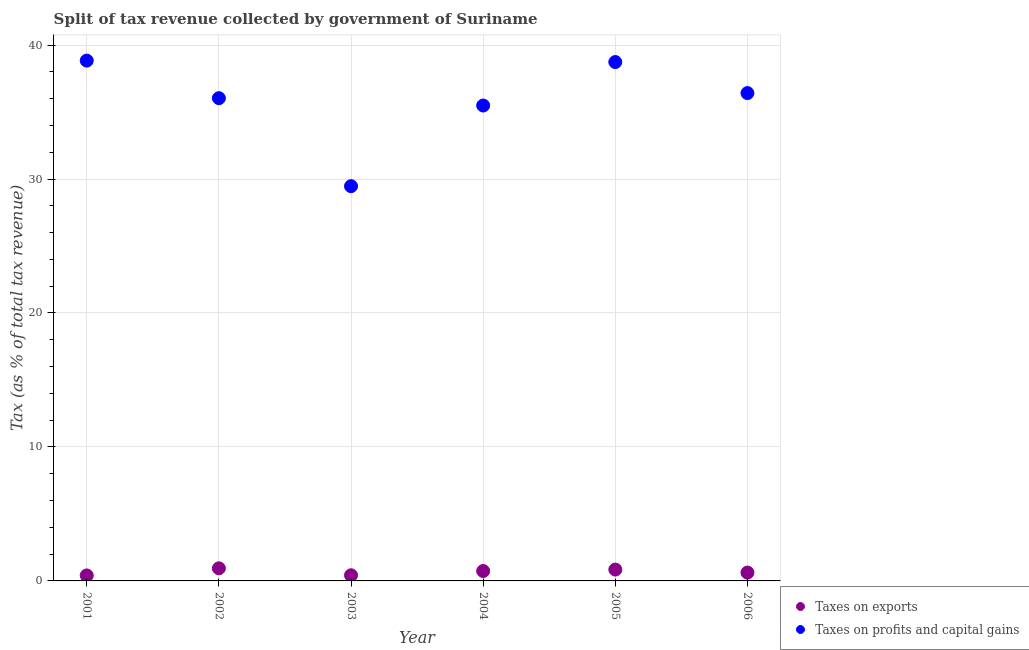What is the percentage of revenue obtained from taxes on profits and capital gains in 2004?
Ensure brevity in your answer.  35.49. Across all years, what is the maximum percentage of revenue obtained from taxes on exports?
Ensure brevity in your answer.  0.94. Across all years, what is the minimum percentage of revenue obtained from taxes on profits and capital gains?
Make the answer very short. 29.47. In which year was the percentage of revenue obtained from taxes on profits and capital gains maximum?
Offer a terse response. 2001. In which year was the percentage of revenue obtained from taxes on profits and capital gains minimum?
Make the answer very short. 2003. What is the total percentage of revenue obtained from taxes on profits and capital gains in the graph?
Give a very brief answer. 214.98. What is the difference between the percentage of revenue obtained from taxes on profits and capital gains in 2005 and that in 2006?
Your response must be concise. 2.32. What is the difference between the percentage of revenue obtained from taxes on profits and capital gains in 2003 and the percentage of revenue obtained from taxes on exports in 2002?
Provide a short and direct response. 28.53. What is the average percentage of revenue obtained from taxes on exports per year?
Provide a succinct answer. 0.66. In the year 2001, what is the difference between the percentage of revenue obtained from taxes on exports and percentage of revenue obtained from taxes on profits and capital gains?
Your answer should be compact. -38.43. What is the ratio of the percentage of revenue obtained from taxes on profits and capital gains in 2002 to that in 2006?
Ensure brevity in your answer.  0.99. Is the percentage of revenue obtained from taxes on exports in 2002 less than that in 2006?
Offer a very short reply. No. What is the difference between the highest and the second highest percentage of revenue obtained from taxes on profits and capital gains?
Offer a very short reply. 0.11. What is the difference between the highest and the lowest percentage of revenue obtained from taxes on profits and capital gains?
Offer a terse response. 9.37. In how many years, is the percentage of revenue obtained from taxes on exports greater than the average percentage of revenue obtained from taxes on exports taken over all years?
Offer a terse response. 3. Is the sum of the percentage of revenue obtained from taxes on exports in 2001 and 2004 greater than the maximum percentage of revenue obtained from taxes on profits and capital gains across all years?
Offer a terse response. No. How many dotlines are there?
Your response must be concise. 2. How many legend labels are there?
Your response must be concise. 2. How are the legend labels stacked?
Provide a succinct answer. Vertical. What is the title of the graph?
Offer a very short reply. Split of tax revenue collected by government of Suriname. What is the label or title of the Y-axis?
Ensure brevity in your answer.  Tax (as % of total tax revenue). What is the Tax (as % of total tax revenue) of Taxes on exports in 2001?
Provide a short and direct response. 0.41. What is the Tax (as % of total tax revenue) of Taxes on profits and capital gains in 2001?
Offer a very short reply. 38.84. What is the Tax (as % of total tax revenue) of Taxes on exports in 2002?
Your response must be concise. 0.94. What is the Tax (as % of total tax revenue) of Taxes on profits and capital gains in 2002?
Offer a very short reply. 36.04. What is the Tax (as % of total tax revenue) of Taxes on exports in 2003?
Give a very brief answer. 0.42. What is the Tax (as % of total tax revenue) in Taxes on profits and capital gains in 2003?
Provide a short and direct response. 29.47. What is the Tax (as % of total tax revenue) in Taxes on exports in 2004?
Give a very brief answer. 0.74. What is the Tax (as % of total tax revenue) in Taxes on profits and capital gains in 2004?
Your answer should be compact. 35.49. What is the Tax (as % of total tax revenue) in Taxes on exports in 2005?
Offer a terse response. 0.85. What is the Tax (as % of total tax revenue) of Taxes on profits and capital gains in 2005?
Offer a very short reply. 38.73. What is the Tax (as % of total tax revenue) in Taxes on exports in 2006?
Your response must be concise. 0.62. What is the Tax (as % of total tax revenue) of Taxes on profits and capital gains in 2006?
Your answer should be very brief. 36.42. Across all years, what is the maximum Tax (as % of total tax revenue) in Taxes on exports?
Give a very brief answer. 0.94. Across all years, what is the maximum Tax (as % of total tax revenue) in Taxes on profits and capital gains?
Your answer should be compact. 38.84. Across all years, what is the minimum Tax (as % of total tax revenue) in Taxes on exports?
Give a very brief answer. 0.41. Across all years, what is the minimum Tax (as % of total tax revenue) of Taxes on profits and capital gains?
Provide a succinct answer. 29.47. What is the total Tax (as % of total tax revenue) of Taxes on exports in the graph?
Ensure brevity in your answer.  3.98. What is the total Tax (as % of total tax revenue) of Taxes on profits and capital gains in the graph?
Provide a succinct answer. 214.98. What is the difference between the Tax (as % of total tax revenue) of Taxes on exports in 2001 and that in 2002?
Make the answer very short. -0.53. What is the difference between the Tax (as % of total tax revenue) in Taxes on profits and capital gains in 2001 and that in 2002?
Your answer should be very brief. 2.8. What is the difference between the Tax (as % of total tax revenue) in Taxes on exports in 2001 and that in 2003?
Provide a short and direct response. -0.01. What is the difference between the Tax (as % of total tax revenue) in Taxes on profits and capital gains in 2001 and that in 2003?
Provide a short and direct response. 9.37. What is the difference between the Tax (as % of total tax revenue) in Taxes on exports in 2001 and that in 2004?
Offer a very short reply. -0.33. What is the difference between the Tax (as % of total tax revenue) of Taxes on profits and capital gains in 2001 and that in 2004?
Provide a succinct answer. 3.35. What is the difference between the Tax (as % of total tax revenue) of Taxes on exports in 2001 and that in 2005?
Your answer should be very brief. -0.44. What is the difference between the Tax (as % of total tax revenue) in Taxes on profits and capital gains in 2001 and that in 2005?
Keep it short and to the point. 0.11. What is the difference between the Tax (as % of total tax revenue) in Taxes on exports in 2001 and that in 2006?
Your response must be concise. -0.21. What is the difference between the Tax (as % of total tax revenue) in Taxes on profits and capital gains in 2001 and that in 2006?
Offer a terse response. 2.42. What is the difference between the Tax (as % of total tax revenue) in Taxes on exports in 2002 and that in 2003?
Provide a succinct answer. 0.52. What is the difference between the Tax (as % of total tax revenue) of Taxes on profits and capital gains in 2002 and that in 2003?
Offer a very short reply. 6.57. What is the difference between the Tax (as % of total tax revenue) of Taxes on exports in 2002 and that in 2004?
Give a very brief answer. 0.2. What is the difference between the Tax (as % of total tax revenue) in Taxes on profits and capital gains in 2002 and that in 2004?
Your response must be concise. 0.55. What is the difference between the Tax (as % of total tax revenue) in Taxes on exports in 2002 and that in 2005?
Make the answer very short. 0.09. What is the difference between the Tax (as % of total tax revenue) in Taxes on profits and capital gains in 2002 and that in 2005?
Your answer should be very brief. -2.7. What is the difference between the Tax (as % of total tax revenue) in Taxes on exports in 2002 and that in 2006?
Provide a short and direct response. 0.32. What is the difference between the Tax (as % of total tax revenue) of Taxes on profits and capital gains in 2002 and that in 2006?
Give a very brief answer. -0.38. What is the difference between the Tax (as % of total tax revenue) of Taxes on exports in 2003 and that in 2004?
Give a very brief answer. -0.32. What is the difference between the Tax (as % of total tax revenue) of Taxes on profits and capital gains in 2003 and that in 2004?
Provide a short and direct response. -6.02. What is the difference between the Tax (as % of total tax revenue) of Taxes on exports in 2003 and that in 2005?
Offer a very short reply. -0.42. What is the difference between the Tax (as % of total tax revenue) in Taxes on profits and capital gains in 2003 and that in 2005?
Ensure brevity in your answer.  -9.27. What is the difference between the Tax (as % of total tax revenue) of Taxes on exports in 2003 and that in 2006?
Offer a very short reply. -0.2. What is the difference between the Tax (as % of total tax revenue) in Taxes on profits and capital gains in 2003 and that in 2006?
Offer a very short reply. -6.95. What is the difference between the Tax (as % of total tax revenue) in Taxes on exports in 2004 and that in 2005?
Provide a short and direct response. -0.11. What is the difference between the Tax (as % of total tax revenue) in Taxes on profits and capital gains in 2004 and that in 2005?
Provide a succinct answer. -3.25. What is the difference between the Tax (as % of total tax revenue) of Taxes on exports in 2004 and that in 2006?
Keep it short and to the point. 0.12. What is the difference between the Tax (as % of total tax revenue) in Taxes on profits and capital gains in 2004 and that in 2006?
Ensure brevity in your answer.  -0.93. What is the difference between the Tax (as % of total tax revenue) of Taxes on exports in 2005 and that in 2006?
Your answer should be very brief. 0.23. What is the difference between the Tax (as % of total tax revenue) of Taxes on profits and capital gains in 2005 and that in 2006?
Your answer should be compact. 2.32. What is the difference between the Tax (as % of total tax revenue) of Taxes on exports in 2001 and the Tax (as % of total tax revenue) of Taxes on profits and capital gains in 2002?
Your answer should be compact. -35.63. What is the difference between the Tax (as % of total tax revenue) of Taxes on exports in 2001 and the Tax (as % of total tax revenue) of Taxes on profits and capital gains in 2003?
Provide a short and direct response. -29.06. What is the difference between the Tax (as % of total tax revenue) in Taxes on exports in 2001 and the Tax (as % of total tax revenue) in Taxes on profits and capital gains in 2004?
Make the answer very short. -35.08. What is the difference between the Tax (as % of total tax revenue) of Taxes on exports in 2001 and the Tax (as % of total tax revenue) of Taxes on profits and capital gains in 2005?
Give a very brief answer. -38.32. What is the difference between the Tax (as % of total tax revenue) in Taxes on exports in 2001 and the Tax (as % of total tax revenue) in Taxes on profits and capital gains in 2006?
Provide a succinct answer. -36.01. What is the difference between the Tax (as % of total tax revenue) in Taxes on exports in 2002 and the Tax (as % of total tax revenue) in Taxes on profits and capital gains in 2003?
Ensure brevity in your answer.  -28.53. What is the difference between the Tax (as % of total tax revenue) in Taxes on exports in 2002 and the Tax (as % of total tax revenue) in Taxes on profits and capital gains in 2004?
Give a very brief answer. -34.55. What is the difference between the Tax (as % of total tax revenue) in Taxes on exports in 2002 and the Tax (as % of total tax revenue) in Taxes on profits and capital gains in 2005?
Your answer should be very brief. -37.79. What is the difference between the Tax (as % of total tax revenue) in Taxes on exports in 2002 and the Tax (as % of total tax revenue) in Taxes on profits and capital gains in 2006?
Your response must be concise. -35.47. What is the difference between the Tax (as % of total tax revenue) in Taxes on exports in 2003 and the Tax (as % of total tax revenue) in Taxes on profits and capital gains in 2004?
Your answer should be very brief. -35.06. What is the difference between the Tax (as % of total tax revenue) in Taxes on exports in 2003 and the Tax (as % of total tax revenue) in Taxes on profits and capital gains in 2005?
Offer a terse response. -38.31. What is the difference between the Tax (as % of total tax revenue) of Taxes on exports in 2003 and the Tax (as % of total tax revenue) of Taxes on profits and capital gains in 2006?
Provide a succinct answer. -35.99. What is the difference between the Tax (as % of total tax revenue) in Taxes on exports in 2004 and the Tax (as % of total tax revenue) in Taxes on profits and capital gains in 2005?
Give a very brief answer. -37.99. What is the difference between the Tax (as % of total tax revenue) in Taxes on exports in 2004 and the Tax (as % of total tax revenue) in Taxes on profits and capital gains in 2006?
Ensure brevity in your answer.  -35.68. What is the difference between the Tax (as % of total tax revenue) of Taxes on exports in 2005 and the Tax (as % of total tax revenue) of Taxes on profits and capital gains in 2006?
Offer a terse response. -35.57. What is the average Tax (as % of total tax revenue) in Taxes on exports per year?
Offer a terse response. 0.66. What is the average Tax (as % of total tax revenue) in Taxes on profits and capital gains per year?
Provide a short and direct response. 35.83. In the year 2001, what is the difference between the Tax (as % of total tax revenue) of Taxes on exports and Tax (as % of total tax revenue) of Taxes on profits and capital gains?
Give a very brief answer. -38.43. In the year 2002, what is the difference between the Tax (as % of total tax revenue) in Taxes on exports and Tax (as % of total tax revenue) in Taxes on profits and capital gains?
Make the answer very short. -35.09. In the year 2003, what is the difference between the Tax (as % of total tax revenue) in Taxes on exports and Tax (as % of total tax revenue) in Taxes on profits and capital gains?
Make the answer very short. -29.04. In the year 2004, what is the difference between the Tax (as % of total tax revenue) of Taxes on exports and Tax (as % of total tax revenue) of Taxes on profits and capital gains?
Ensure brevity in your answer.  -34.75. In the year 2005, what is the difference between the Tax (as % of total tax revenue) in Taxes on exports and Tax (as % of total tax revenue) in Taxes on profits and capital gains?
Offer a very short reply. -37.89. In the year 2006, what is the difference between the Tax (as % of total tax revenue) of Taxes on exports and Tax (as % of total tax revenue) of Taxes on profits and capital gains?
Ensure brevity in your answer.  -35.79. What is the ratio of the Tax (as % of total tax revenue) in Taxes on exports in 2001 to that in 2002?
Your response must be concise. 0.44. What is the ratio of the Tax (as % of total tax revenue) in Taxes on profits and capital gains in 2001 to that in 2002?
Provide a succinct answer. 1.08. What is the ratio of the Tax (as % of total tax revenue) in Taxes on exports in 2001 to that in 2003?
Ensure brevity in your answer.  0.97. What is the ratio of the Tax (as % of total tax revenue) of Taxes on profits and capital gains in 2001 to that in 2003?
Your answer should be very brief. 1.32. What is the ratio of the Tax (as % of total tax revenue) in Taxes on exports in 2001 to that in 2004?
Make the answer very short. 0.55. What is the ratio of the Tax (as % of total tax revenue) in Taxes on profits and capital gains in 2001 to that in 2004?
Offer a very short reply. 1.09. What is the ratio of the Tax (as % of total tax revenue) in Taxes on exports in 2001 to that in 2005?
Your answer should be compact. 0.48. What is the ratio of the Tax (as % of total tax revenue) of Taxes on exports in 2001 to that in 2006?
Offer a very short reply. 0.66. What is the ratio of the Tax (as % of total tax revenue) in Taxes on profits and capital gains in 2001 to that in 2006?
Make the answer very short. 1.07. What is the ratio of the Tax (as % of total tax revenue) in Taxes on exports in 2002 to that in 2003?
Provide a succinct answer. 2.23. What is the ratio of the Tax (as % of total tax revenue) in Taxes on profits and capital gains in 2002 to that in 2003?
Your answer should be compact. 1.22. What is the ratio of the Tax (as % of total tax revenue) in Taxes on exports in 2002 to that in 2004?
Ensure brevity in your answer.  1.27. What is the ratio of the Tax (as % of total tax revenue) in Taxes on profits and capital gains in 2002 to that in 2004?
Make the answer very short. 1.02. What is the ratio of the Tax (as % of total tax revenue) in Taxes on exports in 2002 to that in 2005?
Your answer should be compact. 1.11. What is the ratio of the Tax (as % of total tax revenue) in Taxes on profits and capital gains in 2002 to that in 2005?
Make the answer very short. 0.93. What is the ratio of the Tax (as % of total tax revenue) of Taxes on exports in 2002 to that in 2006?
Your answer should be very brief. 1.52. What is the ratio of the Tax (as % of total tax revenue) in Taxes on profits and capital gains in 2002 to that in 2006?
Your answer should be very brief. 0.99. What is the ratio of the Tax (as % of total tax revenue) of Taxes on exports in 2003 to that in 2004?
Ensure brevity in your answer.  0.57. What is the ratio of the Tax (as % of total tax revenue) of Taxes on profits and capital gains in 2003 to that in 2004?
Your response must be concise. 0.83. What is the ratio of the Tax (as % of total tax revenue) in Taxes on exports in 2003 to that in 2005?
Provide a succinct answer. 0.5. What is the ratio of the Tax (as % of total tax revenue) of Taxes on profits and capital gains in 2003 to that in 2005?
Offer a terse response. 0.76. What is the ratio of the Tax (as % of total tax revenue) of Taxes on exports in 2003 to that in 2006?
Provide a succinct answer. 0.68. What is the ratio of the Tax (as % of total tax revenue) of Taxes on profits and capital gains in 2003 to that in 2006?
Provide a short and direct response. 0.81. What is the ratio of the Tax (as % of total tax revenue) of Taxes on exports in 2004 to that in 2005?
Ensure brevity in your answer.  0.87. What is the ratio of the Tax (as % of total tax revenue) in Taxes on profits and capital gains in 2004 to that in 2005?
Ensure brevity in your answer.  0.92. What is the ratio of the Tax (as % of total tax revenue) of Taxes on exports in 2004 to that in 2006?
Keep it short and to the point. 1.19. What is the ratio of the Tax (as % of total tax revenue) in Taxes on profits and capital gains in 2004 to that in 2006?
Your answer should be compact. 0.97. What is the ratio of the Tax (as % of total tax revenue) in Taxes on exports in 2005 to that in 2006?
Your answer should be very brief. 1.36. What is the ratio of the Tax (as % of total tax revenue) in Taxes on profits and capital gains in 2005 to that in 2006?
Give a very brief answer. 1.06. What is the difference between the highest and the second highest Tax (as % of total tax revenue) in Taxes on exports?
Keep it short and to the point. 0.09. What is the difference between the highest and the second highest Tax (as % of total tax revenue) in Taxes on profits and capital gains?
Provide a short and direct response. 0.11. What is the difference between the highest and the lowest Tax (as % of total tax revenue) of Taxes on exports?
Provide a short and direct response. 0.53. What is the difference between the highest and the lowest Tax (as % of total tax revenue) of Taxes on profits and capital gains?
Offer a very short reply. 9.37. 